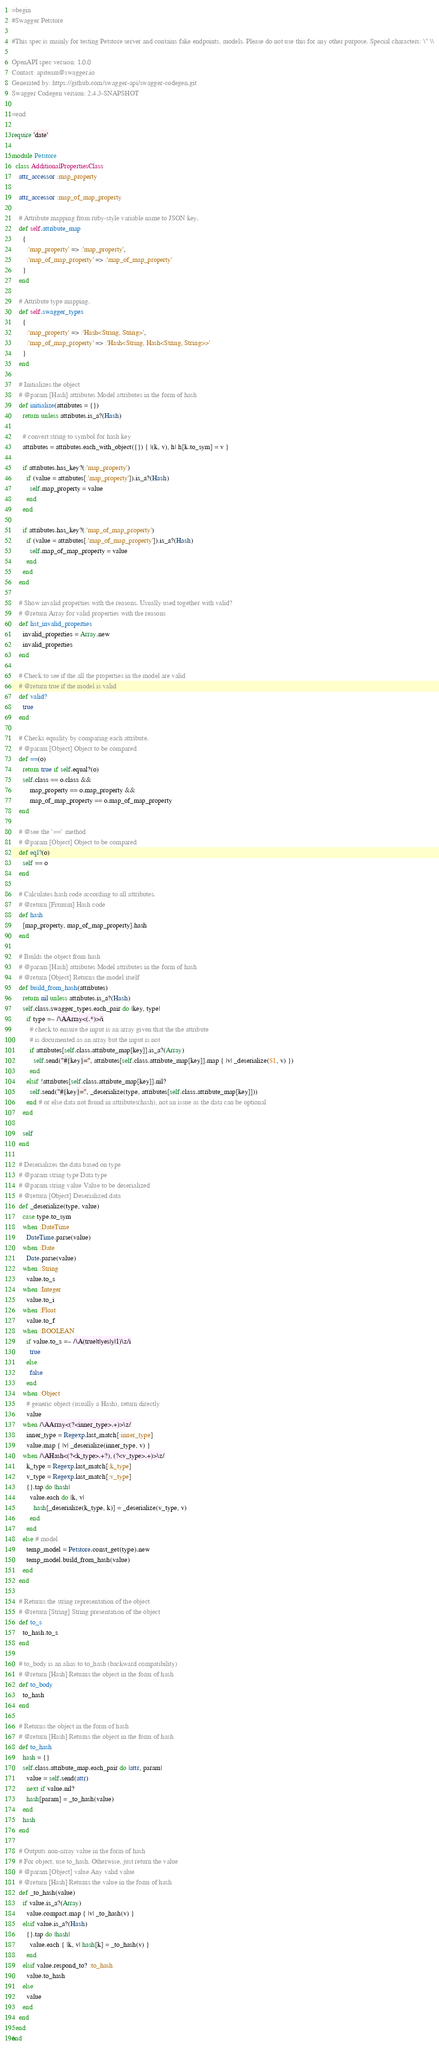Convert code to text. <code><loc_0><loc_0><loc_500><loc_500><_Ruby_>=begin
#Swagger Petstore

#This spec is mainly for testing Petstore server and contains fake endpoints, models. Please do not use this for any other purpose. Special characters: \" \\

OpenAPI spec version: 1.0.0
Contact: apiteam@swagger.io
Generated by: https://github.com/swagger-api/swagger-codegen.git
Swagger Codegen version: 2.4.3-SNAPSHOT

=end

require 'date'

module Petstore
  class AdditionalPropertiesClass
    attr_accessor :map_property

    attr_accessor :map_of_map_property

    # Attribute mapping from ruby-style variable name to JSON key.
    def self.attribute_map
      {
        :'map_property' => :'map_property',
        :'map_of_map_property' => :'map_of_map_property'
      }
    end

    # Attribute type mapping.
    def self.swagger_types
      {
        :'map_property' => :'Hash<String, String>',
        :'map_of_map_property' => :'Hash<String, Hash<String, String>>'
      }
    end

    # Initializes the object
    # @param [Hash] attributes Model attributes in the form of hash
    def initialize(attributes = {})
      return unless attributes.is_a?(Hash)

      # convert string to symbol for hash key
      attributes = attributes.each_with_object({}) { |(k, v), h| h[k.to_sym] = v }

      if attributes.has_key?(:'map_property')
        if (value = attributes[:'map_property']).is_a?(Hash)
          self.map_property = value
        end
      end

      if attributes.has_key?(:'map_of_map_property')
        if (value = attributes[:'map_of_map_property']).is_a?(Hash)
          self.map_of_map_property = value
        end
      end
    end

    # Show invalid properties with the reasons. Usually used together with valid?
    # @return Array for valid properties with the reasons
    def list_invalid_properties
      invalid_properties = Array.new
      invalid_properties
    end

    # Check to see if the all the properties in the model are valid
    # @return true if the model is valid
    def valid?
      true
    end

    # Checks equality by comparing each attribute.
    # @param [Object] Object to be compared
    def ==(o)
      return true if self.equal?(o)
      self.class == o.class &&
          map_property == o.map_property &&
          map_of_map_property == o.map_of_map_property
    end

    # @see the `==` method
    # @param [Object] Object to be compared
    def eql?(o)
      self == o
    end

    # Calculates hash code according to all attributes.
    # @return [Fixnum] Hash code
    def hash
      [map_property, map_of_map_property].hash
    end

    # Builds the object from hash
    # @param [Hash] attributes Model attributes in the form of hash
    # @return [Object] Returns the model itself
    def build_from_hash(attributes)
      return nil unless attributes.is_a?(Hash)
      self.class.swagger_types.each_pair do |key, type|
        if type =~ /\AArray<(.*)>/i
          # check to ensure the input is an array given that the the attribute
          # is documented as an array but the input is not
          if attributes[self.class.attribute_map[key]].is_a?(Array)
            self.send("#{key}=", attributes[self.class.attribute_map[key]].map { |v| _deserialize($1, v) })
          end
        elsif !attributes[self.class.attribute_map[key]].nil?
          self.send("#{key}=", _deserialize(type, attributes[self.class.attribute_map[key]]))
        end # or else data not found in attributes(hash), not an issue as the data can be optional
      end

      self
    end

    # Deserializes the data based on type
    # @param string type Data type
    # @param string value Value to be deserialized
    # @return [Object] Deserialized data
    def _deserialize(type, value)
      case type.to_sym
      when :DateTime
        DateTime.parse(value)
      when :Date
        Date.parse(value)
      when :String
        value.to_s
      when :Integer
        value.to_i
      when :Float
        value.to_f
      when :BOOLEAN
        if value.to_s =~ /\A(true|t|yes|y|1)\z/i
          true
        else
          false
        end
      when :Object
        # generic object (usually a Hash), return directly
        value
      when /\AArray<(?<inner_type>.+)>\z/
        inner_type = Regexp.last_match[:inner_type]
        value.map { |v| _deserialize(inner_type, v) }
      when /\AHash<(?<k_type>.+?), (?<v_type>.+)>\z/
        k_type = Regexp.last_match[:k_type]
        v_type = Regexp.last_match[:v_type]
        {}.tap do |hash|
          value.each do |k, v|
            hash[_deserialize(k_type, k)] = _deserialize(v_type, v)
          end
        end
      else # model
        temp_model = Petstore.const_get(type).new
        temp_model.build_from_hash(value)
      end
    end

    # Returns the string representation of the object
    # @return [String] String presentation of the object
    def to_s
      to_hash.to_s
    end

    # to_body is an alias to to_hash (backward compatibility)
    # @return [Hash] Returns the object in the form of hash
    def to_body
      to_hash
    end

    # Returns the object in the form of hash
    # @return [Hash] Returns the object in the form of hash
    def to_hash
      hash = {}
      self.class.attribute_map.each_pair do |attr, param|
        value = self.send(attr)
        next if value.nil?
        hash[param] = _to_hash(value)
      end
      hash
    end

    # Outputs non-array value in the form of hash
    # For object, use to_hash. Otherwise, just return the value
    # @param [Object] value Any valid value
    # @return [Hash] Returns the value in the form of hash
    def _to_hash(value)
      if value.is_a?(Array)
        value.compact.map { |v| _to_hash(v) }
      elsif value.is_a?(Hash)
        {}.tap do |hash|
          value.each { |k, v| hash[k] = _to_hash(v) }
        end
      elsif value.respond_to? :to_hash
        value.to_hash
      else
        value
      end
    end
  end
end
</code> 